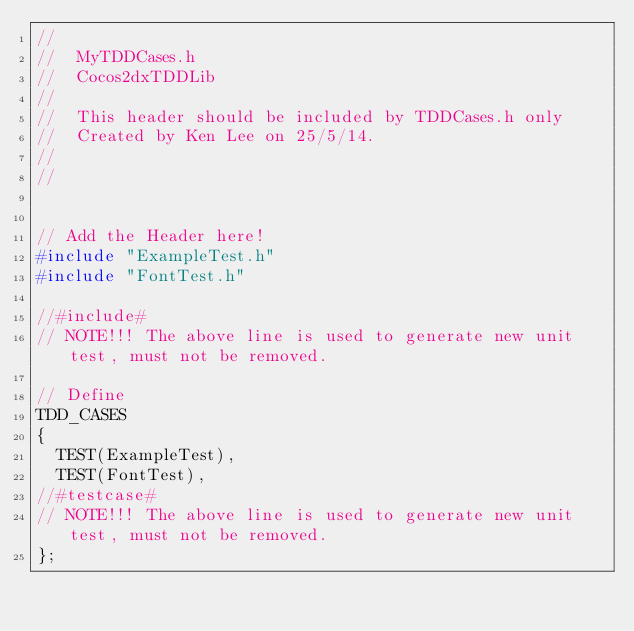Convert code to text. <code><loc_0><loc_0><loc_500><loc_500><_C_>//
//  MyTDDCases.h
//  Cocos2dxTDDLib
//
//	This header should be included by TDDCases.h only
//  Created by Ken Lee on 25/5/14.
//
//


// Add the Header here!
#include "ExampleTest.h"
#include "FontTest.h"

//#include#
// NOTE!!! The above line is used to generate new unit test, must not be removed.

// Define
TDD_CASES
{
	TEST(ExampleTest),
	TEST(FontTest), 
//#testcase#
// NOTE!!! The above line is used to generate new unit test, must not be removed.
};


</code> 